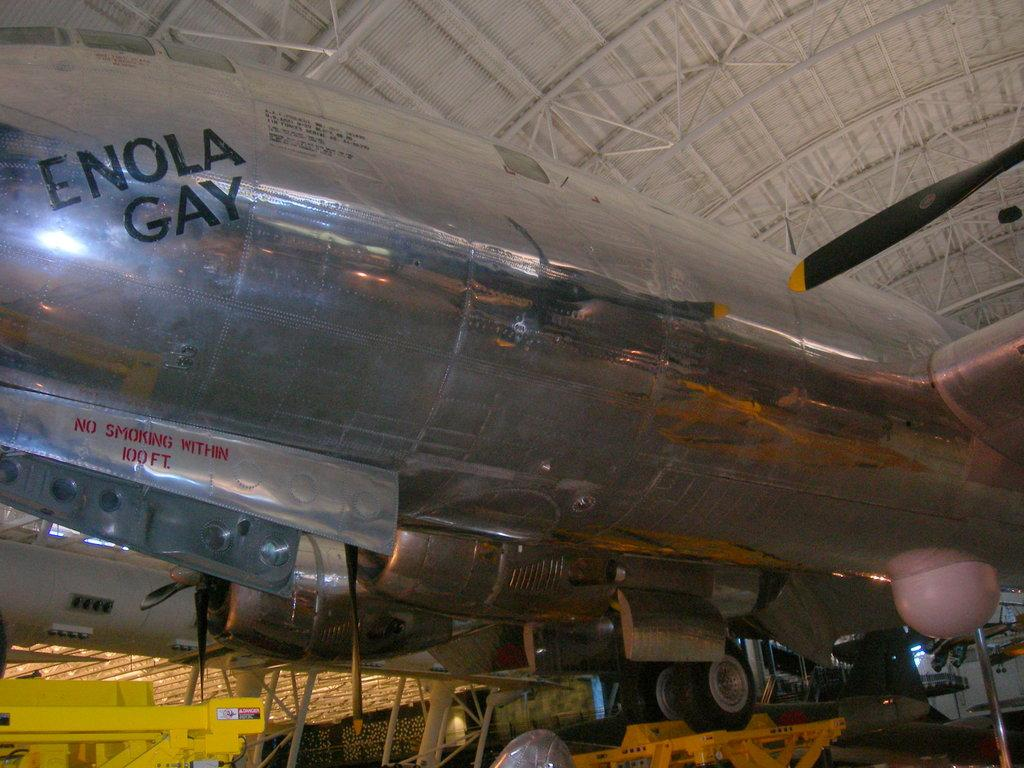<image>
Share a concise interpretation of the image provided. a silver plans has the words ENOLA GAy on it 